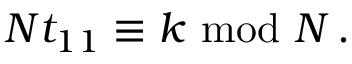Convert formula to latex. <formula><loc_0><loc_0><loc_500><loc_500>N t _ { 1 1 } \equiv k \ m o d \ N \, .</formula> 